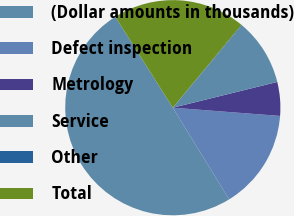Convert chart. <chart><loc_0><loc_0><loc_500><loc_500><pie_chart><fcel>(Dollar amounts in thousands)<fcel>Defect inspection<fcel>Metrology<fcel>Service<fcel>Other<fcel>Total<nl><fcel>49.8%<fcel>15.01%<fcel>5.07%<fcel>10.04%<fcel>0.1%<fcel>19.98%<nl></chart> 